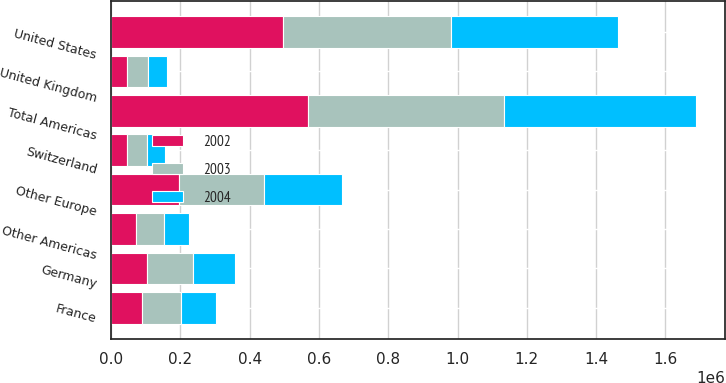Convert chart. <chart><loc_0><loc_0><loc_500><loc_500><stacked_bar_chart><ecel><fcel>United States<fcel>Other Americas<fcel>Total Americas<fcel>Germany<fcel>France<fcel>United Kingdom<fcel>Switzerland<fcel>Other Europe<nl><fcel>2003<fcel>486660<fcel>79316<fcel>565976<fcel>131862<fcel>112669<fcel>58734<fcel>56669<fcel>245323<nl><fcel>2004<fcel>480418<fcel>73750<fcel>554168<fcel>122706<fcel>99303<fcel>55215<fcel>51750<fcel>224790<nl><fcel>2002<fcel>494913<fcel>72754<fcel>567667<fcel>104311<fcel>90046<fcel>47228<fcel>46274<fcel>197225<nl></chart> 